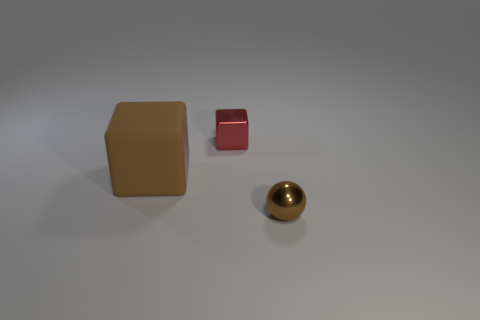Add 2 small red things. How many objects exist? 5 Subtract all cubes. How many objects are left? 1 Add 3 tiny yellow spheres. How many tiny yellow spheres exist? 3 Subtract 0 yellow blocks. How many objects are left? 3 Subtract all red things. Subtract all big matte blocks. How many objects are left? 1 Add 1 matte things. How many matte things are left? 2 